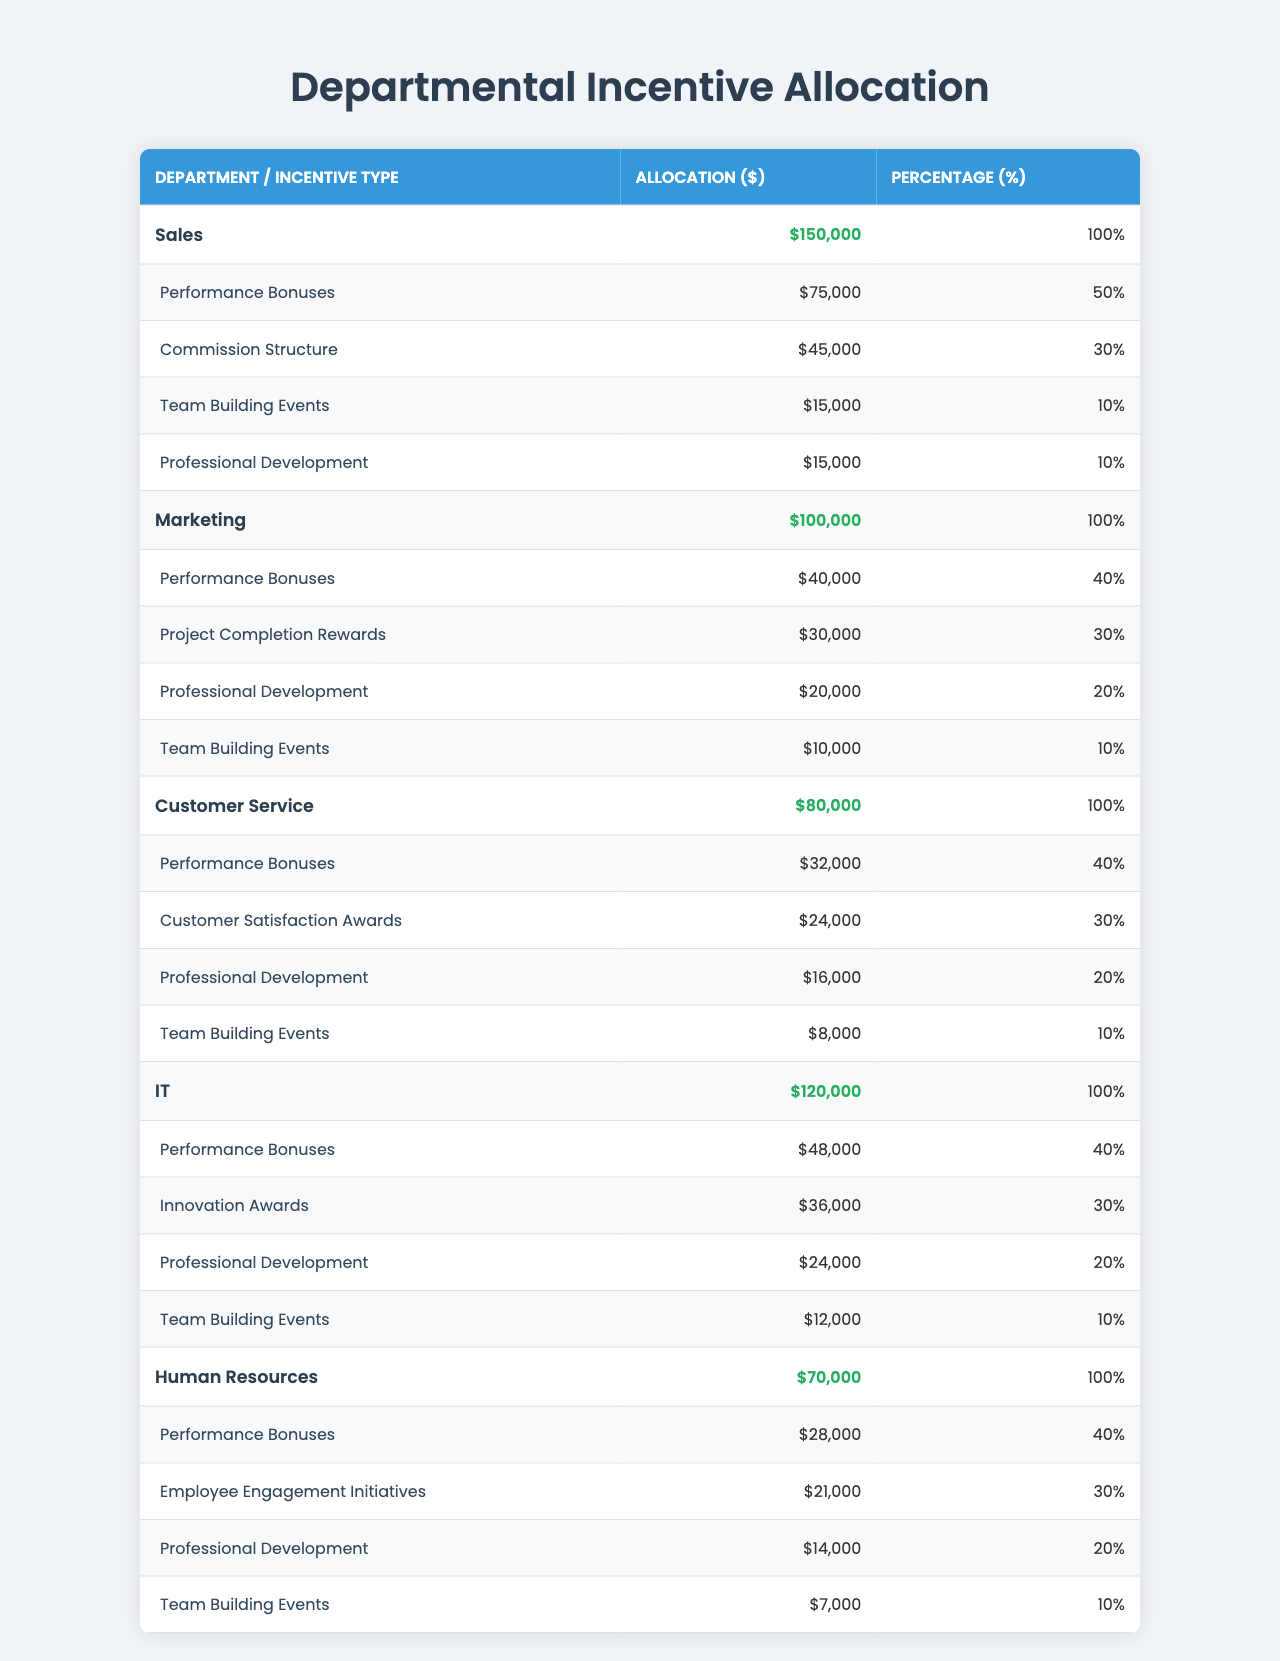What is the total budget allocated for the Sales department? The total budget for the Sales department is explicitly stated in the table. It is listed as $150,000.
Answer: $150,000 Which department has the highest allocation for Performance Bonuses? By looking at the allocation for Performance Bonuses across all departments, the Sales department has the highest amount allocated at $75,000.
Answer: Sales What percentage of the total budget for the Marketing department is allocated to Project Completion Rewards? The allocation for Project Completion Rewards is $30,000, and the total budget for Marketing is $100,000. To find the percentage: (30,000 / 100,000) * 100 = 30%.
Answer: 30% How much more does the IT department spend on Innovation Awards compared to the Customer Service department's allocation for Customer Satisfaction Awards? The IT department allocates $36,000 for Innovation Awards, while the Customer Service department allocates $24,000 for Customer Satisfaction Awards. The difference is 36,000 - 24,000 = $12,000.
Answer: $12,000 Is it true that Human Resources spends the least on Team Building Events among all departments? By comparing the allocations for Team Building Events: Human Resources allocates $7,000, Customer Service allocates $8,000, Marketing allocates $10,000, Sales allocates $15,000, and IT allocates $12,000. Human Resources does have the least allocation.
Answer: Yes What is the total amount allocated for Professional Development across all departments? To find the total allocation for Professional Development, add the amounts from each department: 15,000 (Sales) + 20,000 (Marketing) + 16,000 (Customer Service) + 24,000 (IT) + 14,000 (Human Resources) = 89,000.
Answer: $89,000 What is the average allocation for Team Building Events across all departments? The allocations for Team Building Events are: $15,000 (Sales), $10,000 (Marketing), $8,000 (Customer Service), $12,000 (IT), and $7,000 (Human Resources). To find the average: (15,000 + 10,000 + 8,000 + 12,000 + 7,000) / 5 = 52,000 / 5 = 10,400.
Answer: $10,400 Which department has the smallest total budget, and what is that budget? By comparing the total budgets of all departments, Human Resources has the smallest total budget at $70,000.
Answer: Human Resources; $70,000 What is the combined allocation for all types of incentives in the Customer Service department? Adding the allocations in the Customer Service department gives: 32,000 (Performance Bonuses) + 24,000 (Customer Satisfaction Awards) + 16,000 (Professional Development) + 8,000 (Team Building Events) = 80,000.
Answer: $80,000 Which two departments have the same percentage allocation for Professional Development? Both IT and Sales allocate 20% for Professional Development. This can be confirmed by reviewing the respective rows in the table.
Answer: IT and Sales How much of the total budget does Performance Bonuses represent for the IT department? The IT department allocates $48,000 for Performance Bonuses from a total budget of $120,000. To find the percentage: (48,000 / 120,000) * 100 = 40%.
Answer: 40% 